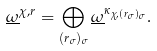Convert formula to latex. <formula><loc_0><loc_0><loc_500><loc_500>\underline { \omega } ^ { \chi , r } = \bigoplus _ { ( r _ { \sigma } ) _ { \sigma } } \underline { \omega } ^ { \kappa _ { \chi , ( r _ { \sigma } ) _ { \sigma } } } .</formula> 